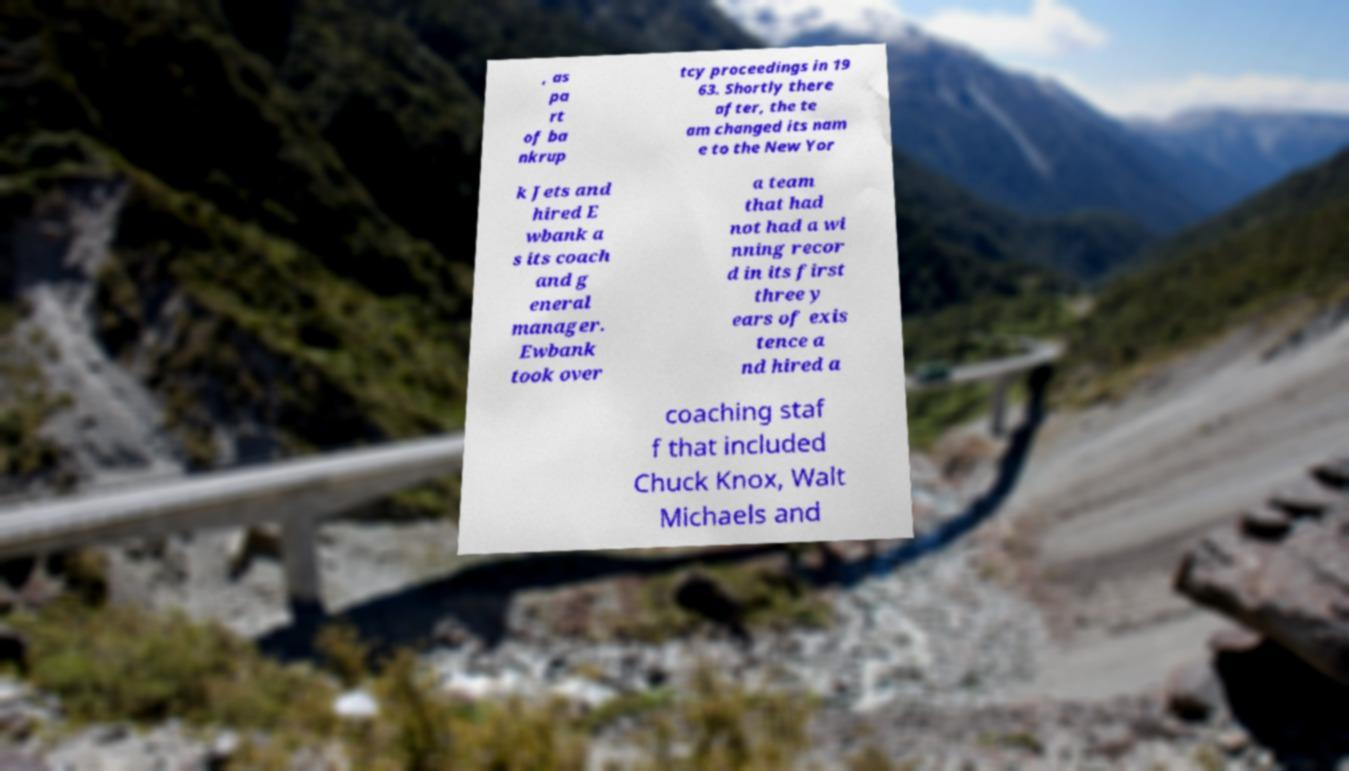Could you extract and type out the text from this image? , as pa rt of ba nkrup tcy proceedings in 19 63. Shortly there after, the te am changed its nam e to the New Yor k Jets and hired E wbank a s its coach and g eneral manager. Ewbank took over a team that had not had a wi nning recor d in its first three y ears of exis tence a nd hired a coaching staf f that included Chuck Knox, Walt Michaels and 